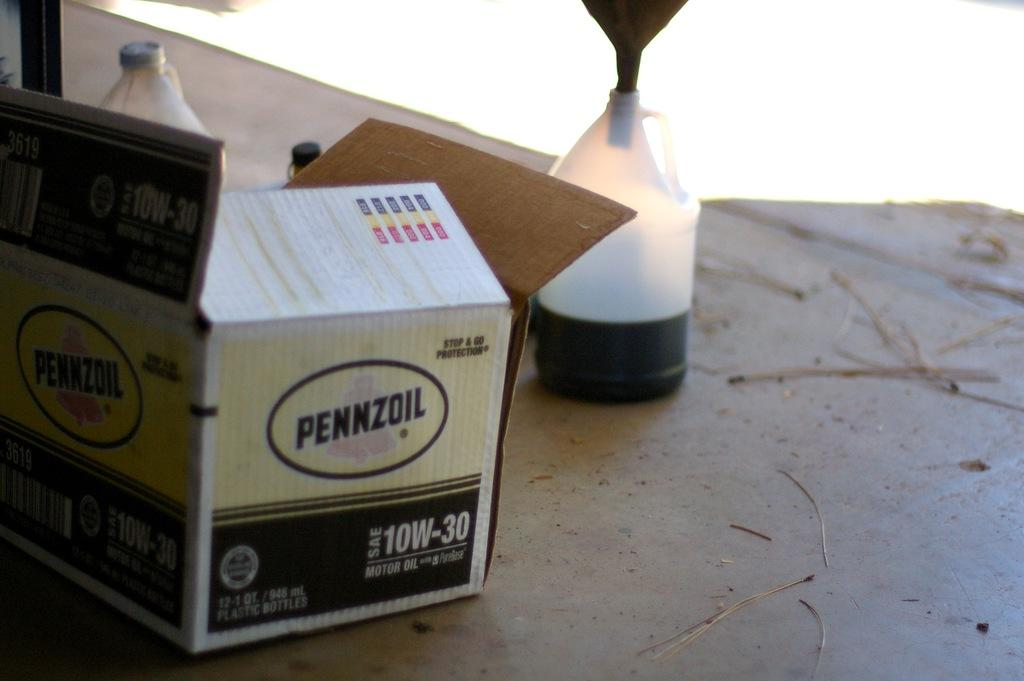<image>
Write a terse but informative summary of the picture. An open yellow and black box of Pennzoil 